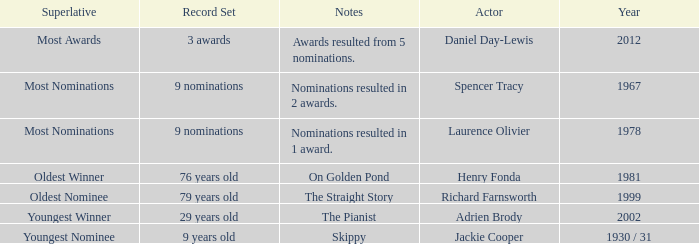What year was the the youngest nominee a winner? 1930 / 31. 